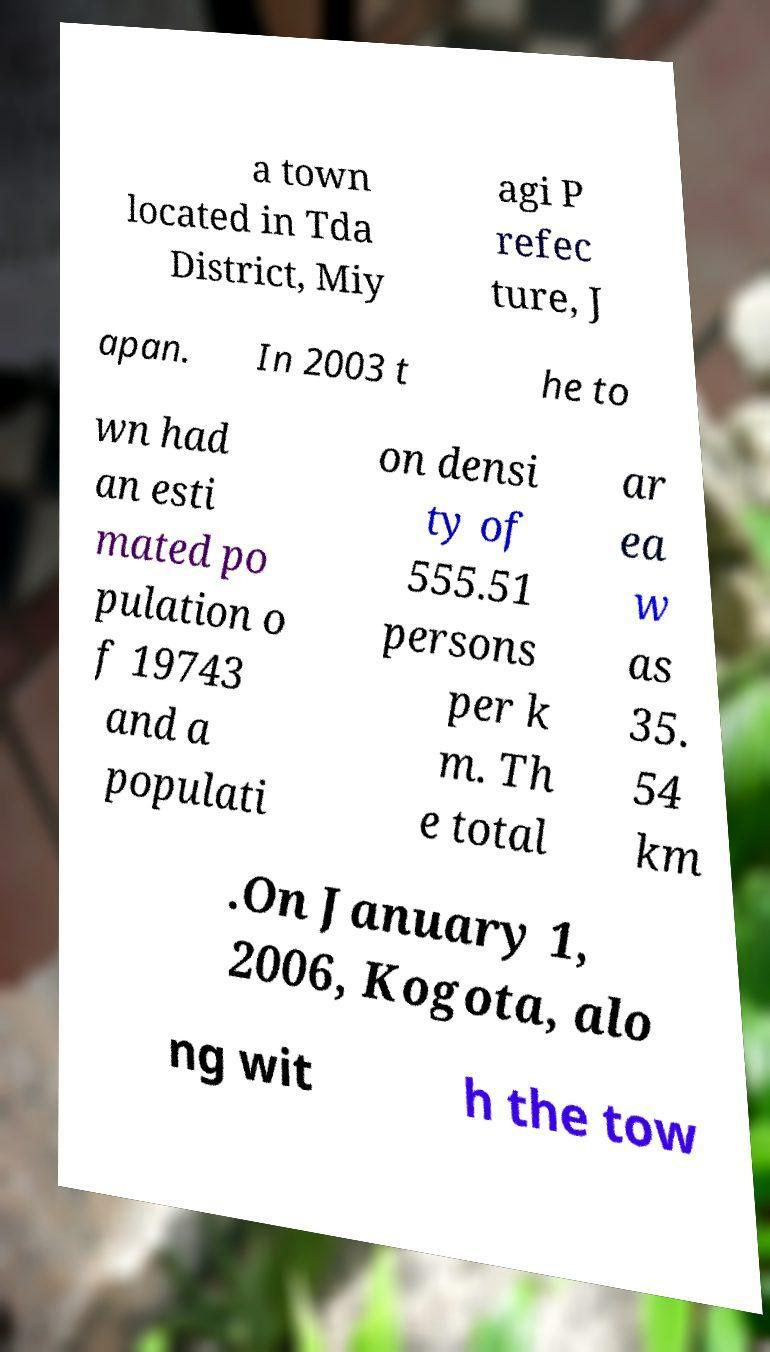There's text embedded in this image that I need extracted. Can you transcribe it verbatim? a town located in Tda District, Miy agi P refec ture, J apan. In 2003 t he to wn had an esti mated po pulation o f 19743 and a populati on densi ty of 555.51 persons per k m. Th e total ar ea w as 35. 54 km .On January 1, 2006, Kogota, alo ng wit h the tow 